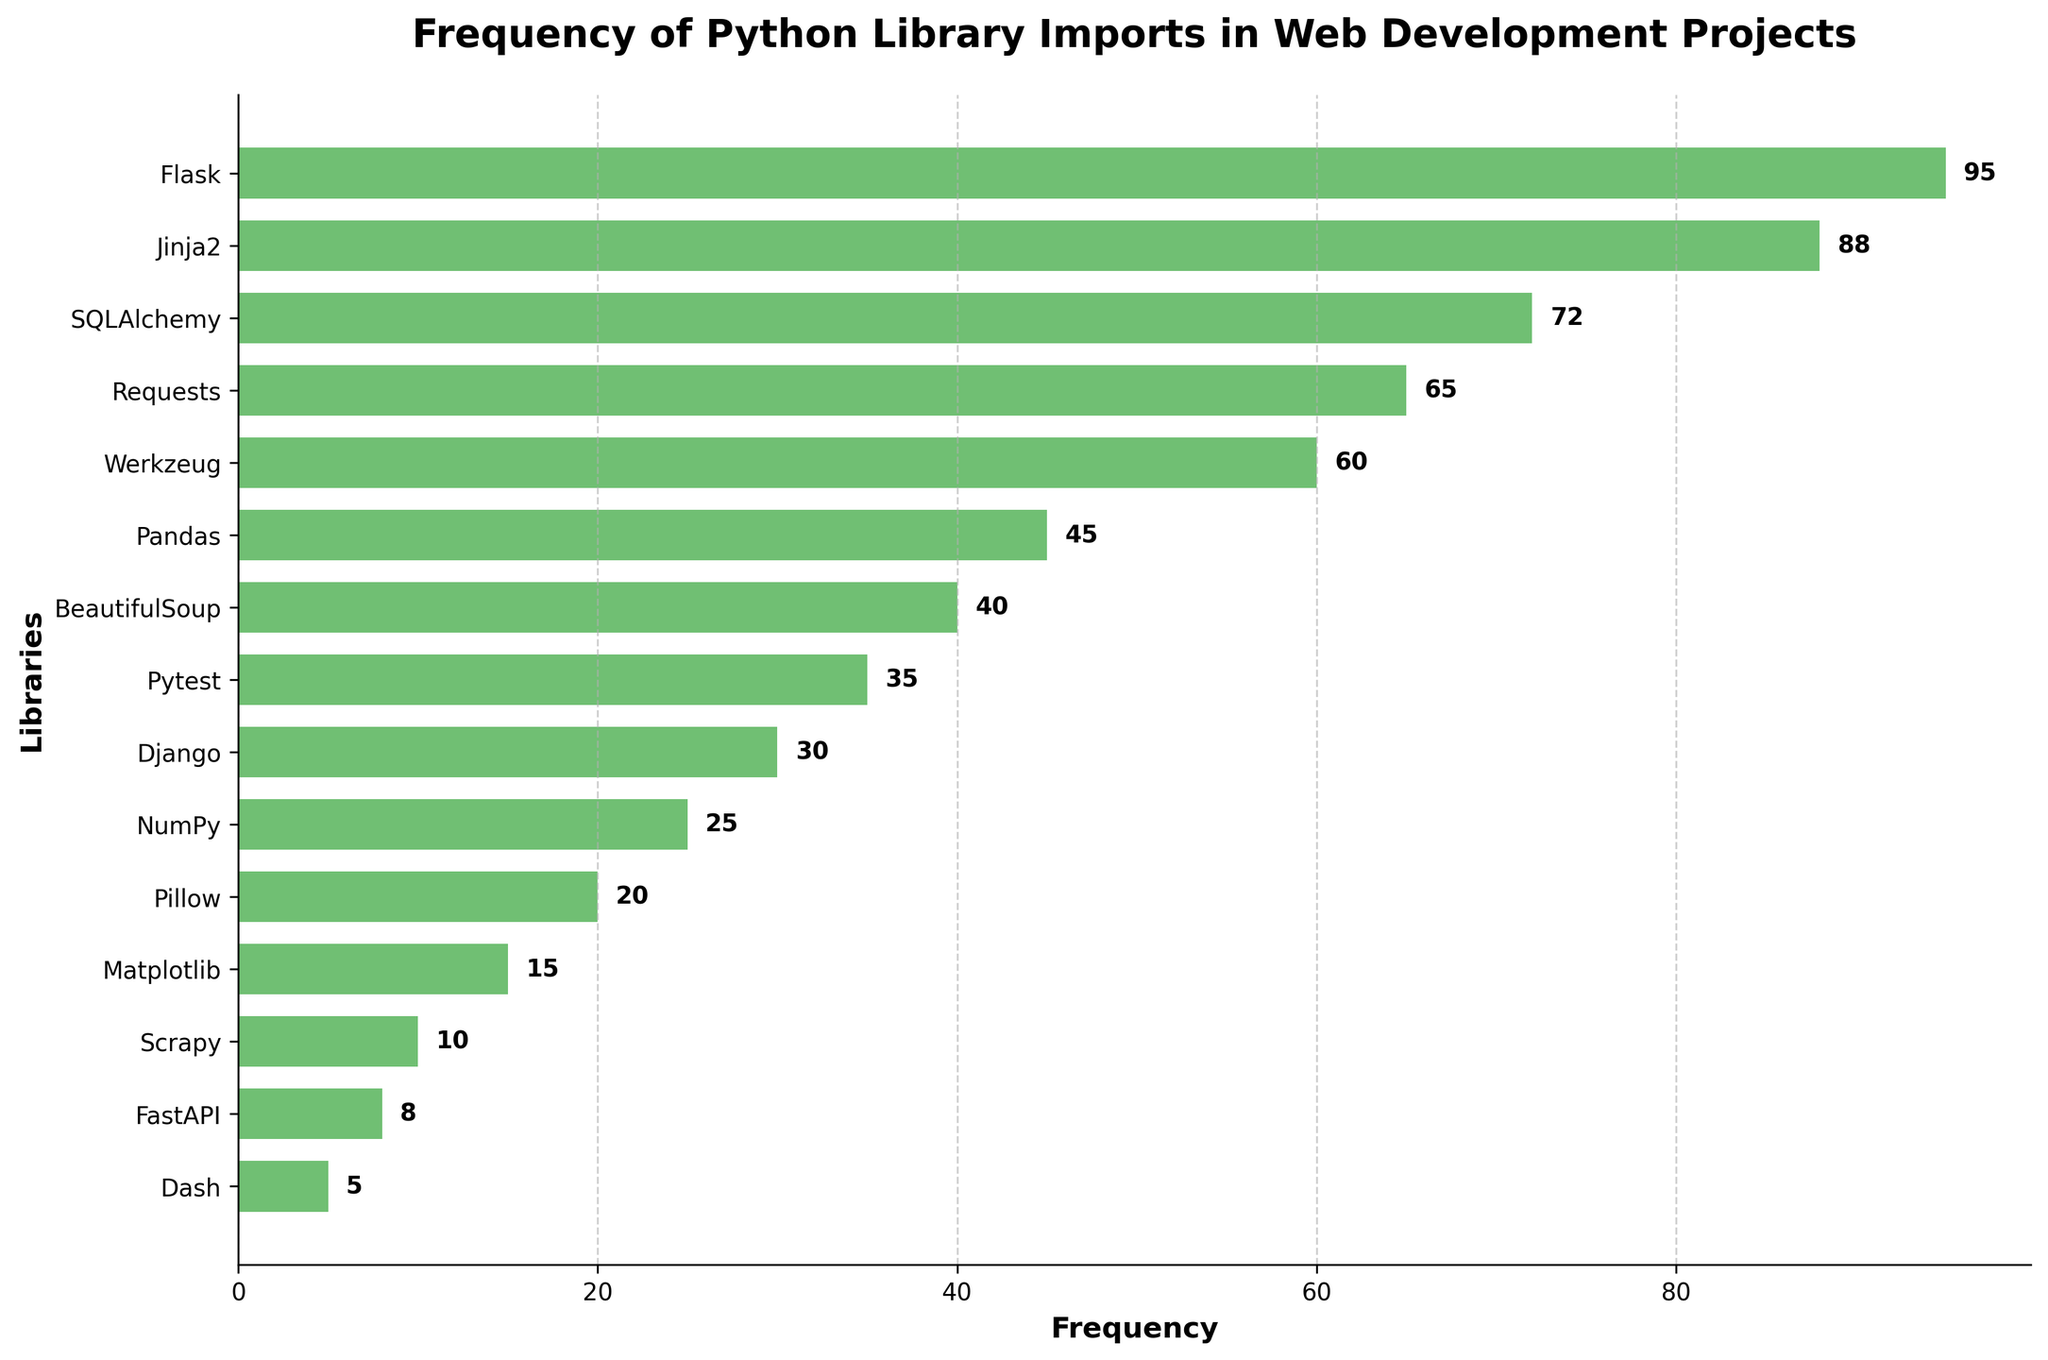What is the title of the figure? The title of the figure is usually located at the top and is used to give a brief description of the content. In this case, the title reads "Frequency of Python Library Imports in Web Development Projects."
Answer: "Frequency of Python Library Imports in Web Development Projects" How many libraries are represented in the plot? By counting the library names displayed along the y-axis, we can determine the number of libraries included in the plot. There are 15 libraries listed.
Answer: 15 What color is used to represent the bars in the plot? The color of the bars is given in the description as "#4CAF50." Identifying the specific color on a plot can be challenging without a legend, but it is typically a shade of green.
Answer: Green What is the sum of the frequencies of Flask and Django? Add the frequency of Flask, which is 95, and the frequency of Django, which is 30. This gives us 95 + 30 = 125.
Answer: 125 Which library has the median frequency, and what is that frequency? To find the median frequency, first, list the frequencies in ascending order: 5, 8, 10, 15, 20, 25, 30, 35, 40, 45, 60, 65, 72, 88, 95. There are 15 values, so the median is the 8th value in this ordered list, which is 35 (corresponding to the library Pytest).
Answer: Pytest, 35 Which library appears more frequently: Pandas or BeautifulSoup? By how much? Pandas has a frequency of 45 and BeautifulSoup has a frequency of 40. Subtract 40 from 45 to get 5. Therefore, Pandas is imported 5 times more often than BeautifulSoup.
Answer: Pandas by 5 Is Requests more frequently used than SQLAlchemy? Compare the frequencies: Requests has a frequency of 65 while SQLAlchemy has a frequency of 72. Requests is used less frequently than SQLAlchemy.
Answer: No Which library is the most frequently imported? The horizontal density plot has the longest bar at the top, corresponding to the library Flask with a frequency of 95.
Answer: Flask Which library is the least frequently imported? The shortest bar at the bottom of the plot corresponds to the library Dash, with a frequency of 5.
Answer: Dash 